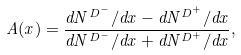<formula> <loc_0><loc_0><loc_500><loc_500>A ( x ) = \frac { d N ^ { D ^ { - } } / d x - d N ^ { D ^ { + } } / d x } { d N ^ { D ^ { - } } / d x + d N ^ { D ^ { + } } / d x } ,</formula> 